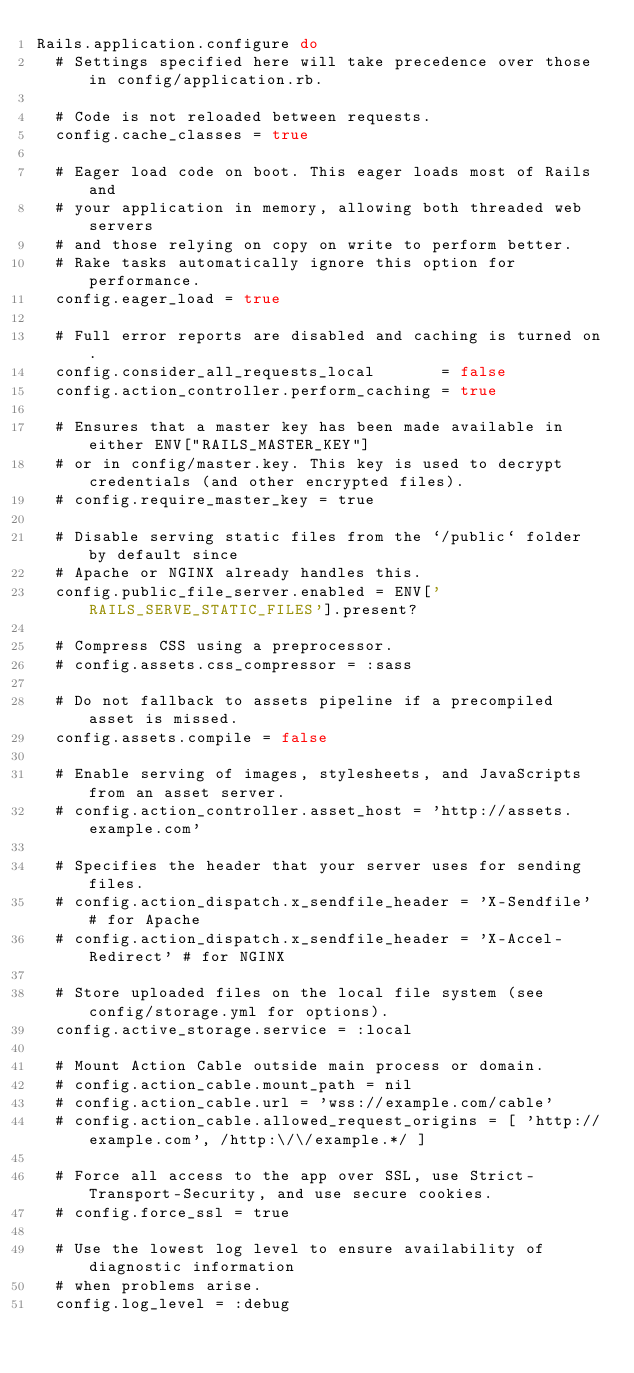<code> <loc_0><loc_0><loc_500><loc_500><_Ruby_>Rails.application.configure do
  # Settings specified here will take precedence over those in config/application.rb.

  # Code is not reloaded between requests.
  config.cache_classes = true

  # Eager load code on boot. This eager loads most of Rails and
  # your application in memory, allowing both threaded web servers
  # and those relying on copy on write to perform better.
  # Rake tasks automatically ignore this option for performance.
  config.eager_load = true

  # Full error reports are disabled and caching is turned on.
  config.consider_all_requests_local       = false
  config.action_controller.perform_caching = true

  # Ensures that a master key has been made available in either ENV["RAILS_MASTER_KEY"]
  # or in config/master.key. This key is used to decrypt credentials (and other encrypted files).
  # config.require_master_key = true

  # Disable serving static files from the `/public` folder by default since
  # Apache or NGINX already handles this.
  config.public_file_server.enabled = ENV['RAILS_SERVE_STATIC_FILES'].present?

  # Compress CSS using a preprocessor.
  # config.assets.css_compressor = :sass

  # Do not fallback to assets pipeline if a precompiled asset is missed.
  config.assets.compile = false

  # Enable serving of images, stylesheets, and JavaScripts from an asset server.
  # config.action_controller.asset_host = 'http://assets.example.com'

  # Specifies the header that your server uses for sending files.
  # config.action_dispatch.x_sendfile_header = 'X-Sendfile' # for Apache
  # config.action_dispatch.x_sendfile_header = 'X-Accel-Redirect' # for NGINX

  # Store uploaded files on the local file system (see config/storage.yml for options).
  config.active_storage.service = :local

  # Mount Action Cable outside main process or domain.
  # config.action_cable.mount_path = nil
  # config.action_cable.url = 'wss://example.com/cable'
  # config.action_cable.allowed_request_origins = [ 'http://example.com', /http:\/\/example.*/ ]

  # Force all access to the app over SSL, use Strict-Transport-Security, and use secure cookies.
  # config.force_ssl = true

  # Use the lowest log level to ensure availability of diagnostic information
  # when problems arise.
  config.log_level = :debug
</code> 